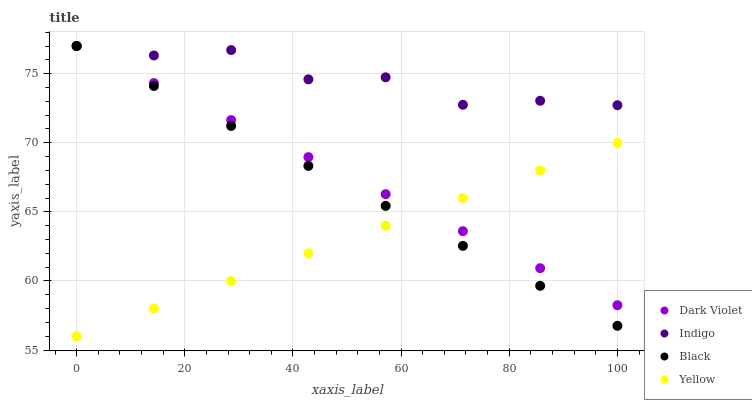Does Yellow have the minimum area under the curve?
Answer yes or no. Yes. Does Indigo have the maximum area under the curve?
Answer yes or no. Yes. Does Indigo have the minimum area under the curve?
Answer yes or no. No. Does Yellow have the maximum area under the curve?
Answer yes or no. No. Is Yellow the smoothest?
Answer yes or no. Yes. Is Indigo the roughest?
Answer yes or no. Yes. Is Indigo the smoothest?
Answer yes or no. No. Is Yellow the roughest?
Answer yes or no. No. Does Yellow have the lowest value?
Answer yes or no. Yes. Does Indigo have the lowest value?
Answer yes or no. No. Does Dark Violet have the highest value?
Answer yes or no. Yes. Does Yellow have the highest value?
Answer yes or no. No. Is Yellow less than Indigo?
Answer yes or no. Yes. Is Indigo greater than Yellow?
Answer yes or no. Yes. Does Dark Violet intersect Yellow?
Answer yes or no. Yes. Is Dark Violet less than Yellow?
Answer yes or no. No. Is Dark Violet greater than Yellow?
Answer yes or no. No. Does Yellow intersect Indigo?
Answer yes or no. No. 